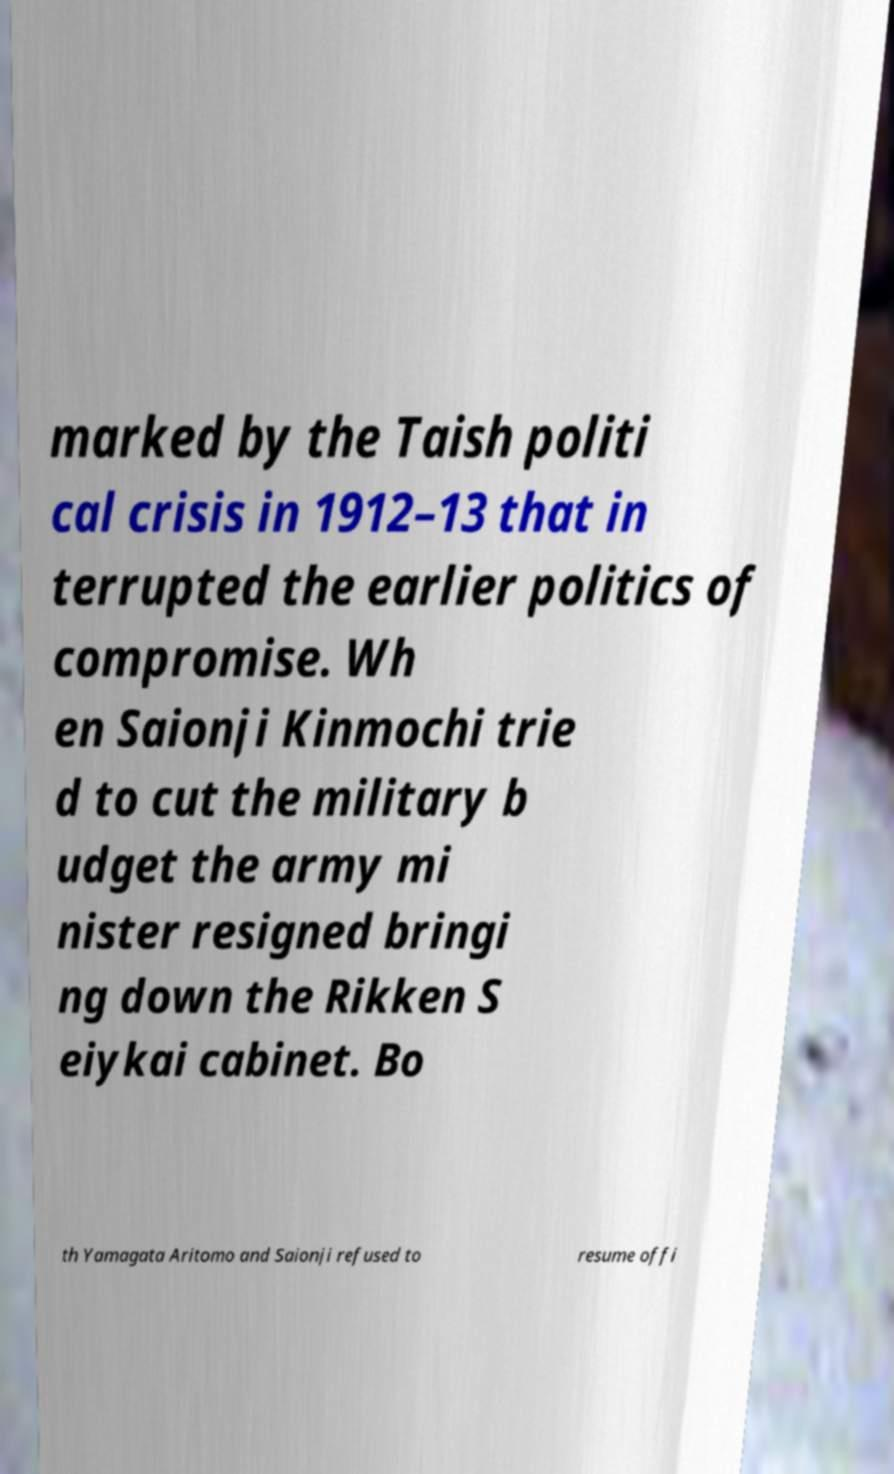Can you accurately transcribe the text from the provided image for me? marked by the Taish politi cal crisis in 1912–13 that in terrupted the earlier politics of compromise. Wh en Saionji Kinmochi trie d to cut the military b udget the army mi nister resigned bringi ng down the Rikken S eiykai cabinet. Bo th Yamagata Aritomo and Saionji refused to resume offi 